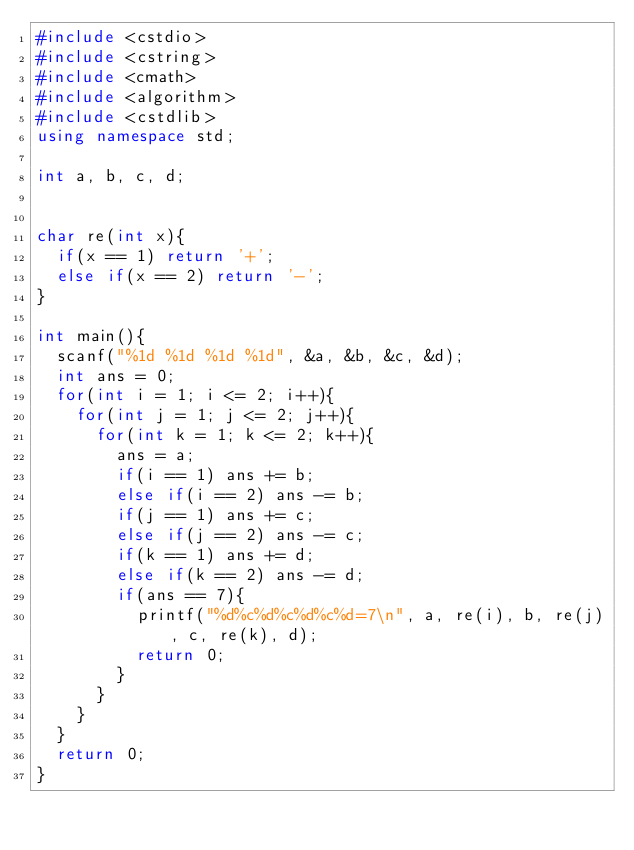<code> <loc_0><loc_0><loc_500><loc_500><_C++_>#include <cstdio>
#include <cstring>
#include <cmath>
#include <algorithm>
#include <cstdlib>
using namespace std;

int a, b, c, d;


char re(int x){
	if(x == 1) return '+';
	else if(x == 2) return '-';
}

int main(){
	scanf("%1d %1d %1d %1d", &a, &b, &c, &d);
	int ans = 0;
	for(int i = 1; i <= 2; i++){
		for(int j = 1; j <= 2; j++){
			for(int k = 1; k <= 2; k++){
				ans = a;
				if(i == 1) ans += b;
				else if(i == 2) ans -= b;
				if(j == 1) ans += c;
				else if(j == 2) ans -= c;
				if(k == 1) ans += d;
				else if(k == 2) ans -= d;
				if(ans == 7){
					printf("%d%c%d%c%d%c%d=7\n", a, re(i), b, re(j), c, re(k), d);
					return 0;
				}
			}
		}
	}
	return 0;
}</code> 